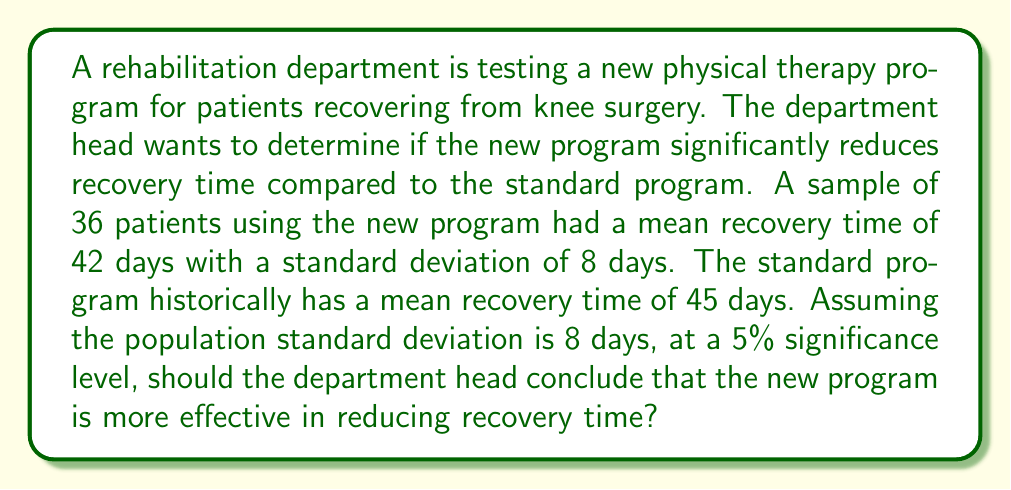Give your solution to this math problem. To analyze the effectiveness of the new program, we'll use a one-tailed z-test for the population mean. We'll follow these steps:

1) Define the null and alternative hypotheses:
   $H_0: \mu = 45$ (new program is not more effective)
   $H_a: \mu < 45$ (new program is more effective)

2) Calculate the z-score:
   $z = \frac{\bar{x} - \mu_0}{\sigma / \sqrt{n}}$
   
   Where:
   $\bar{x} = 42$ (sample mean)
   $\mu_0 = 45$ (hypothesized population mean)
   $\sigma = 8$ (population standard deviation)
   $n = 36$ (sample size)

   $z = \frac{42 - 45}{8 / \sqrt{36}} = \frac{-3}{8/6} = \frac{-3}{1.333} = -2.25$

3) Find the critical value:
   At 5% significance level (one-tailed), $z_{\text{critical}} = -1.645$

4) Compare the calculated z-score with the critical value:
   $-2.25 < -1.645$

5) Make a decision:
   Since the calculated z-score is less than the critical value, we reject the null hypothesis.

6) Interpret the result:
   There is sufficient evidence to conclude that the new program is more effective in reducing recovery time at a 5% significance level.
Answer: Reject $H_0$; new program is more effective. 